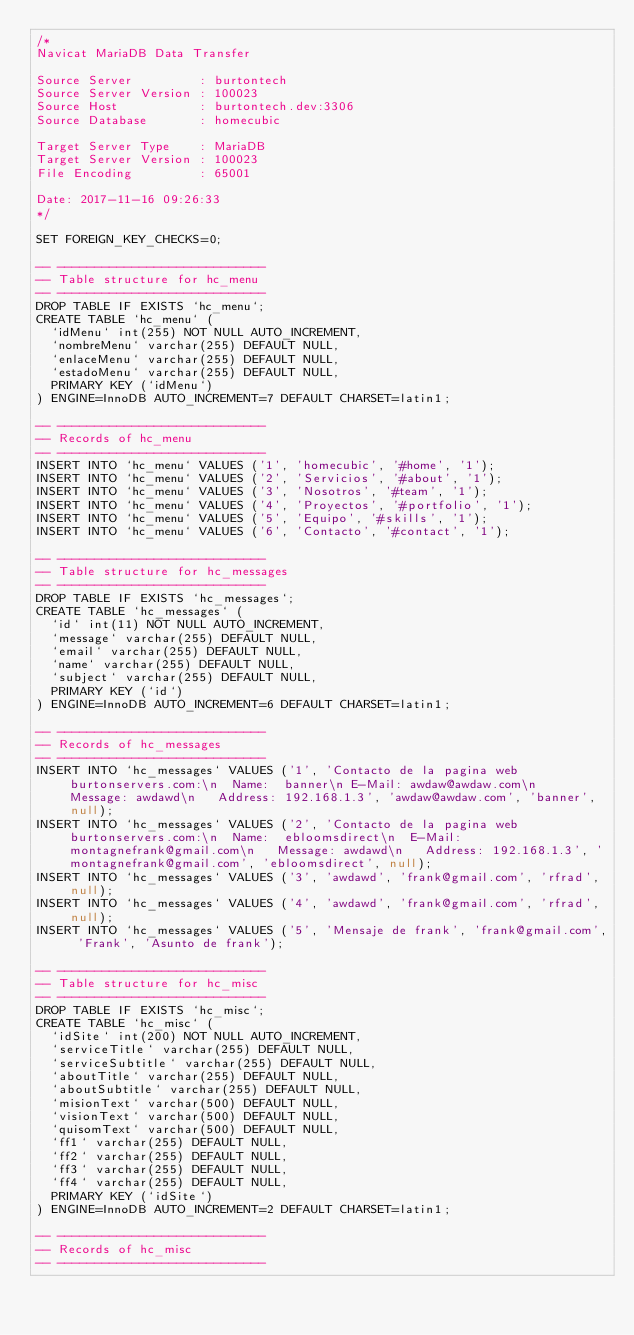<code> <loc_0><loc_0><loc_500><loc_500><_SQL_>/*
Navicat MariaDB Data Transfer

Source Server         : burtontech
Source Server Version : 100023
Source Host           : burtontech.dev:3306
Source Database       : homecubic

Target Server Type    : MariaDB
Target Server Version : 100023
File Encoding         : 65001

Date: 2017-11-16 09:26:33
*/

SET FOREIGN_KEY_CHECKS=0;

-- ----------------------------
-- Table structure for hc_menu
-- ----------------------------
DROP TABLE IF EXISTS `hc_menu`;
CREATE TABLE `hc_menu` (
  `idMenu` int(255) NOT NULL AUTO_INCREMENT,
  `nombreMenu` varchar(255) DEFAULT NULL,
  `enlaceMenu` varchar(255) DEFAULT NULL,
  `estadoMenu` varchar(255) DEFAULT NULL,
  PRIMARY KEY (`idMenu`)
) ENGINE=InnoDB AUTO_INCREMENT=7 DEFAULT CHARSET=latin1;

-- ----------------------------
-- Records of hc_menu
-- ----------------------------
INSERT INTO `hc_menu` VALUES ('1', 'homecubic', '#home', '1');
INSERT INTO `hc_menu` VALUES ('2', 'Servicios', '#about', '1');
INSERT INTO `hc_menu` VALUES ('3', 'Nosotros', '#team', '1');
INSERT INTO `hc_menu` VALUES ('4', 'Proyectos', '#portfolio', '1');
INSERT INTO `hc_menu` VALUES ('5', 'Equipo', '#skills', '1');
INSERT INTO `hc_menu` VALUES ('6', 'Contacto', '#contact', '1');

-- ----------------------------
-- Table structure for hc_messages
-- ----------------------------
DROP TABLE IF EXISTS `hc_messages`;
CREATE TABLE `hc_messages` (
  `id` int(11) NOT NULL AUTO_INCREMENT,
  `message` varchar(255) DEFAULT NULL,
  `email` varchar(255) DEFAULT NULL,
  `name` varchar(255) DEFAULT NULL,
  `subject` varchar(255) DEFAULT NULL,
  PRIMARY KEY (`id`)
) ENGINE=InnoDB AUTO_INCREMENT=6 DEFAULT CHARSET=latin1;

-- ----------------------------
-- Records of hc_messages
-- ----------------------------
INSERT INTO `hc_messages` VALUES ('1', 'Contacto de la pagina web burtonservers.com:\n	Name:  banner\n	E-Mail: awdaw@awdaw.com\n	Message: awdawd\n	Address: 192.168.1.3', 'awdaw@awdaw.com', 'banner', null);
INSERT INTO `hc_messages` VALUES ('2', 'Contacto de la pagina web burtonservers.com:\n	Name:  ebloomsdirect\n	E-Mail: montagnefrank@gmail.com\n	Message: awdawd\n	Address: 192.168.1.3', 'montagnefrank@gmail.com', 'ebloomsdirect', null);
INSERT INTO `hc_messages` VALUES ('3', 'awdawd', 'frank@gmail.com', 'rfrad', null);
INSERT INTO `hc_messages` VALUES ('4', 'awdawd', 'frank@gmail.com', 'rfrad', null);
INSERT INTO `hc_messages` VALUES ('5', 'Mensaje de frank', 'frank@gmail.com', 'Frank', 'Asunto de frank');

-- ----------------------------
-- Table structure for hc_misc
-- ----------------------------
DROP TABLE IF EXISTS `hc_misc`;
CREATE TABLE `hc_misc` (
  `idSite` int(200) NOT NULL AUTO_INCREMENT,
  `serviceTitle` varchar(255) DEFAULT NULL,
  `serviceSubtitle` varchar(255) DEFAULT NULL,
  `aboutTitle` varchar(255) DEFAULT NULL,
  `aboutSubtitle` varchar(255) DEFAULT NULL,
  `misionText` varchar(500) DEFAULT NULL,
  `visionText` varchar(500) DEFAULT NULL,
  `quisomText` varchar(500) DEFAULT NULL,
  `ff1` varchar(255) DEFAULT NULL,
  `ff2` varchar(255) DEFAULT NULL,
  `ff3` varchar(255) DEFAULT NULL,
  `ff4` varchar(255) DEFAULT NULL,
  PRIMARY KEY (`idSite`)
) ENGINE=InnoDB AUTO_INCREMENT=2 DEFAULT CHARSET=latin1;

-- ----------------------------
-- Records of hc_misc
-- ----------------------------</code> 